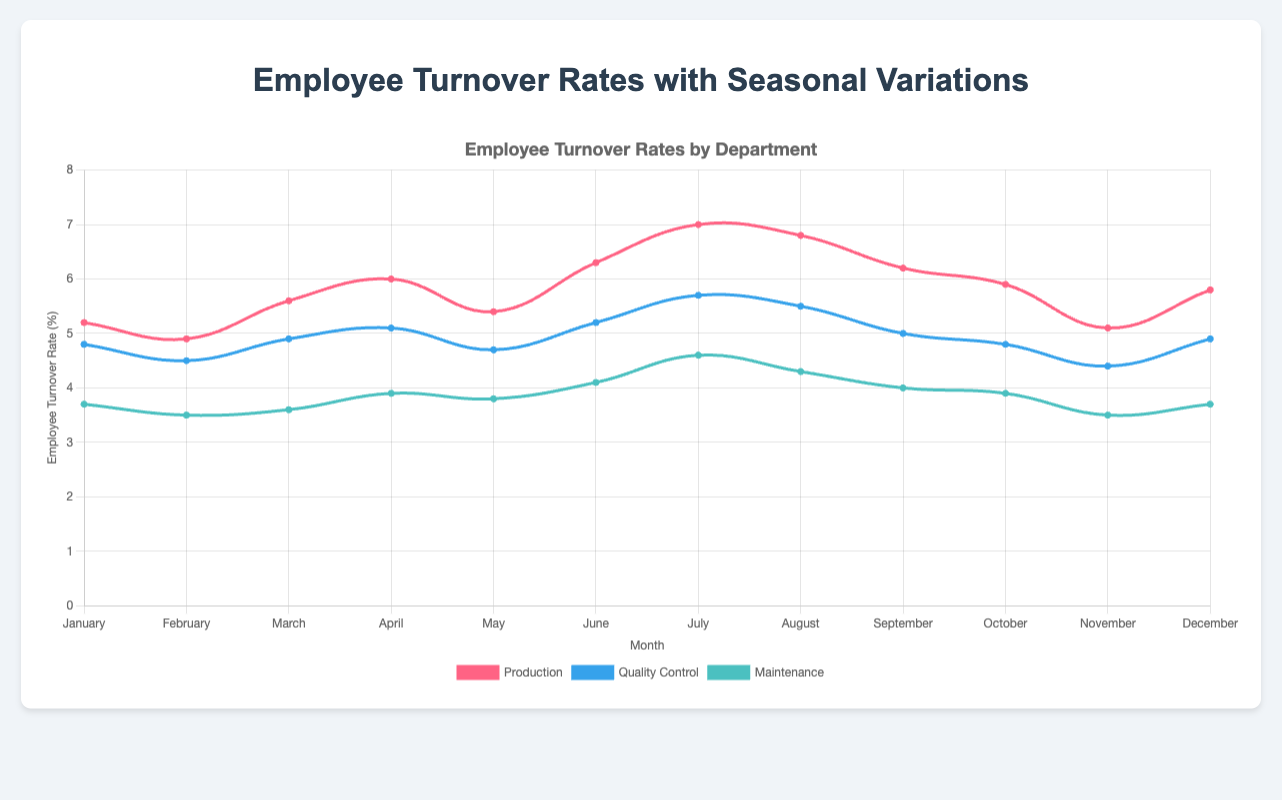What month has the highest employee turnover rate in the Production department? To determine the month with the highest employee turnover rate in the Production department, look for the peak point on the line plotted for Production, which is colored in red. In July, the turnover rate reaches its highest value.
Answer: July What is the average employee turnover rate for the Quality Control department across the year? To find the average turnover rate, sum the monthly turnover rates for Quality Control (4.8 + 4.5 + 4.9 + 5.1 + 4.7 + 5.2 + 5.7 + 5.5 + 5.0 + 4.8 + 4.4 + 4.9) and divide by 12. The total is 59.5, and the average is 59.5/12.
Answer: 4.96% Which department has the lowest turnover rate in August? Identify the value of the turnover rates for each department in August by looking at the points on that month's vertical line. Compare the values to find the smallest one: Production (6.8), Quality Control (5.5), and Maintenance (4.3). Maintenance has the lowest turnover rate.
Answer: Maintenance In which months does the Maintenance department experience a turnover rate lower than 4%? Check the turnover rates for Maintenance for each month and see when the value is less than 4%. These months are February (3.5), March (3.6), May (3.8), November (3.5), and December (3.7).
Answer: February, March, May, November, December How does the turnover rate change in the Production department from June to July? Look at the points corresponding to June and July for the Production department and note the values: June (6.3) and July (7.0). Subtract the June rate from the July rate (7.0 - 6.3) to find the change.
Answer: Increase by 0.7% What is the difference between the highest and lowest turnover rates in the Quality Control department? Identify the highest and lowest turnover rates for Quality Control across all months: highest is 5.7 (July) and lowest is 4.4 (November). Subtract the smallest value from the largest (5.7 - 4.4).
Answer: 1.3% Compare the turnover rates in the Production and Maintenance departments in April. Which department has a higher turnover rate? Observe the turnover rates for Production and Maintenance in April. Production has a turnover rate of 6.0, and Maintenance has 3.9. Production has a higher turnover rate.
Answer: Production In which month does the Quality Control department experience a turnover rate of 5.0%? Find the month where the turnover rate for Quality Control is exactly 5.0%. It occurs in September.
Answer: September What is the combined turnover rate for all departments in May? Sum the turnover rates for all departments in May: Production (5.4), Quality Control (4.7), and Maintenance (3.8). The total is 5.4 + 4.7 + 3.8.
Answer: 13.9% If the Maintenance department wants to maintain a turnover rate below 4.0% next year, in how many months did it meet this goal this year? Evaluate the data for Maintenance and count the months where the turnover rate was below 4.0%: February (3.5), March (3.6), May (3.8), November (3.5), December (3.7). This occurs in 5 months.
Answer: 5 months 